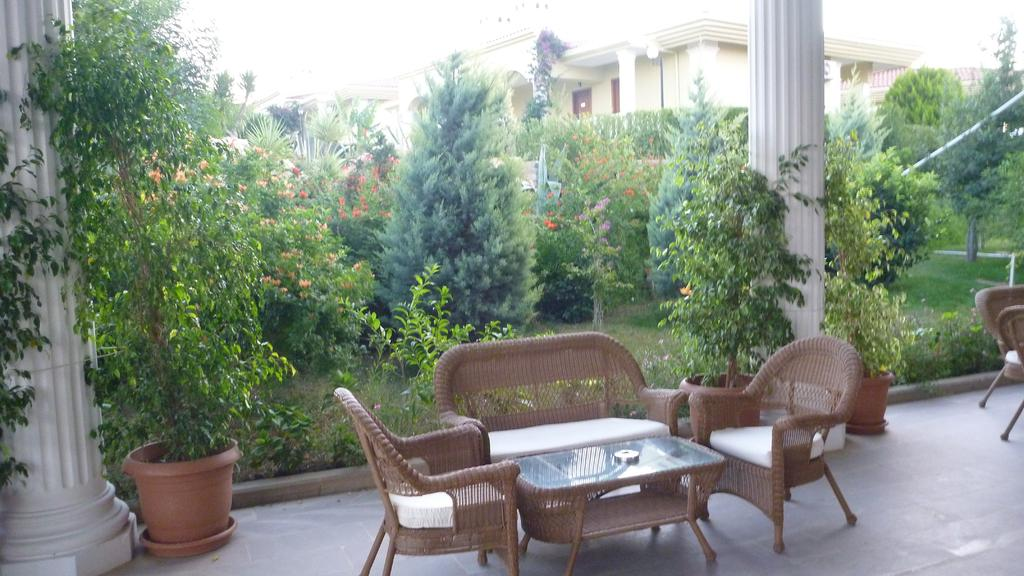Where is the image taken? The image is taken in a garden. What type of furniture is present in the garden? There is a sofa and chairs in the garden. How are the chairs arranged in relation to the sofa? The chairs are beside the sofa. What is placed between the sofa and chairs? There is a table between the sofa and chairs. What can be seen in the background of the image? There is a building, trees, and a flower pot in the background of the image. What type of elbow can be seen in the image? There is no elbow present in the image; it is a garden setting with furniture and a background. 